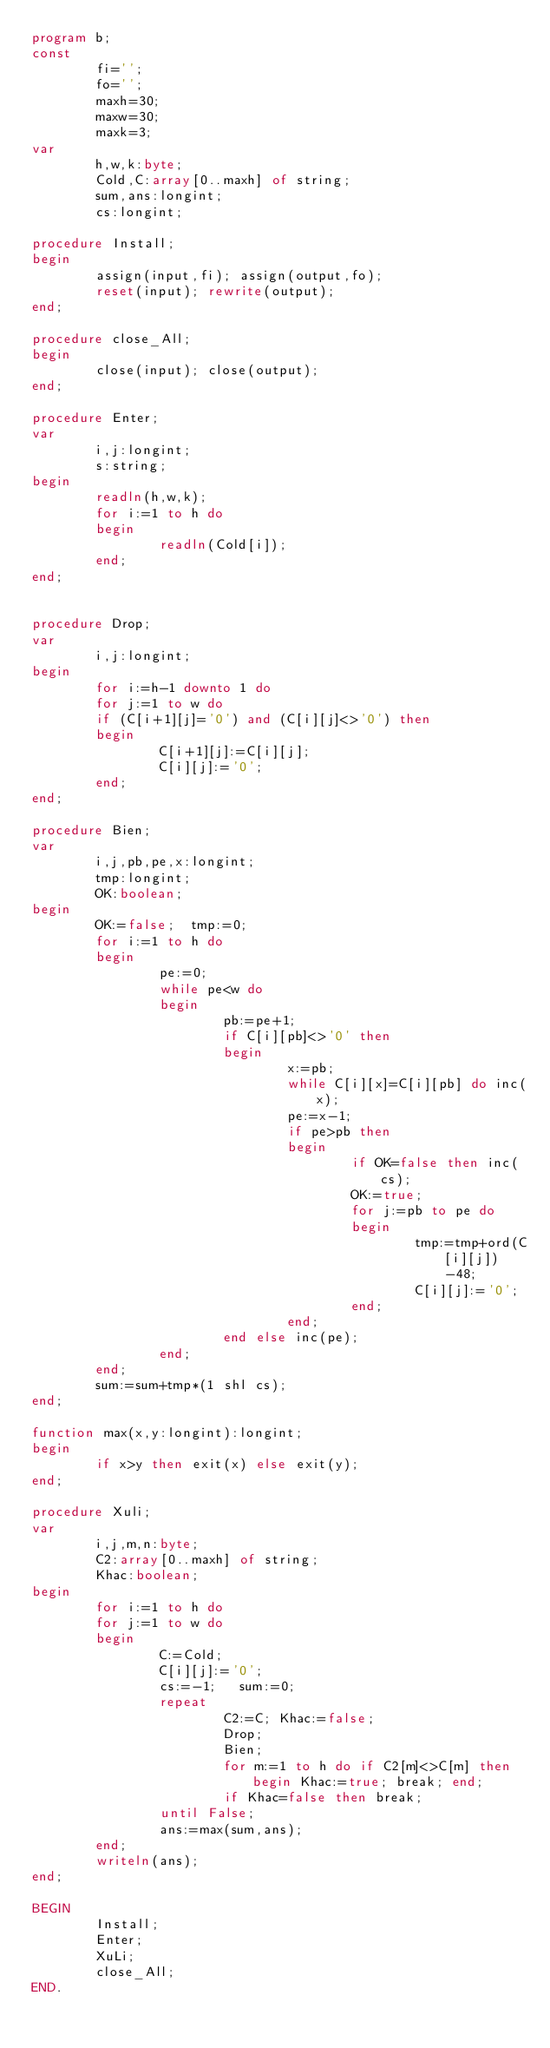Convert code to text. <code><loc_0><loc_0><loc_500><loc_500><_Pascal_>program b;
const
        fi='';
        fo='';
        maxh=30;
        maxw=30;
        maxk=3;
var
        h,w,k:byte;
        Cold,C:array[0..maxh] of string;
        sum,ans:longint;
        cs:longint;

procedure Install;
begin
        assign(input,fi); assign(output,fo);
        reset(input); rewrite(output);
end;

procedure close_All;
begin
        close(input); close(output);
end;

procedure Enter;
var
        i,j:longint;
        s:string;
begin
        readln(h,w,k);
        for i:=1 to h do
        begin
                readln(Cold[i]);
        end;
end;


procedure Drop;
var
        i,j:longint;
begin
        for i:=h-1 downto 1 do
        for j:=1 to w do
        if (C[i+1][j]='0') and (C[i][j]<>'0') then
        begin
                C[i+1][j]:=C[i][j];
                C[i][j]:='0';
        end;
end;

procedure Bien;
var
        i,j,pb,pe,x:longint;
        tmp:longint;
        OK:boolean;
begin
        OK:=false;  tmp:=0;
        for i:=1 to h do
        begin
                pe:=0;
                while pe<w do
                begin
                        pb:=pe+1;
                        if C[i][pb]<>'0' then
                        begin
                                x:=pb;
                                while C[i][x]=C[i][pb] do inc(x);
                                pe:=x-1;
                                if pe>pb then
                                begin
                                        if OK=false then inc(cs);
                                        OK:=true;
                                        for j:=pb to pe do
                                        begin
                                                tmp:=tmp+ord(C[i][j])-48;
                                                C[i][j]:='0';
                                        end;
                                end;
                        end else inc(pe);
                end;
        end;
        sum:=sum+tmp*(1 shl cs);
end;

function max(x,y:longint):longint;
begin
        if x>y then exit(x) else exit(y);
end;

procedure Xuli;
var
        i,j,m,n:byte;
        C2:array[0..maxh] of string;
        Khac:boolean;
begin
        for i:=1 to h do
        for j:=1 to w do
        begin
                C:=Cold;
                C[i][j]:='0';
                cs:=-1;   sum:=0;
                repeat
                        C2:=C; Khac:=false;
                        Drop;
                        Bien;
                        for m:=1 to h do if C2[m]<>C[m] then begin Khac:=true; break; end;
                        if Khac=false then break;
                until False;
                ans:=max(sum,ans);
        end;
        writeln(ans);
end;

BEGIN
        Install;
        Enter;
        XuLi;
        close_All;
END.
</code> 